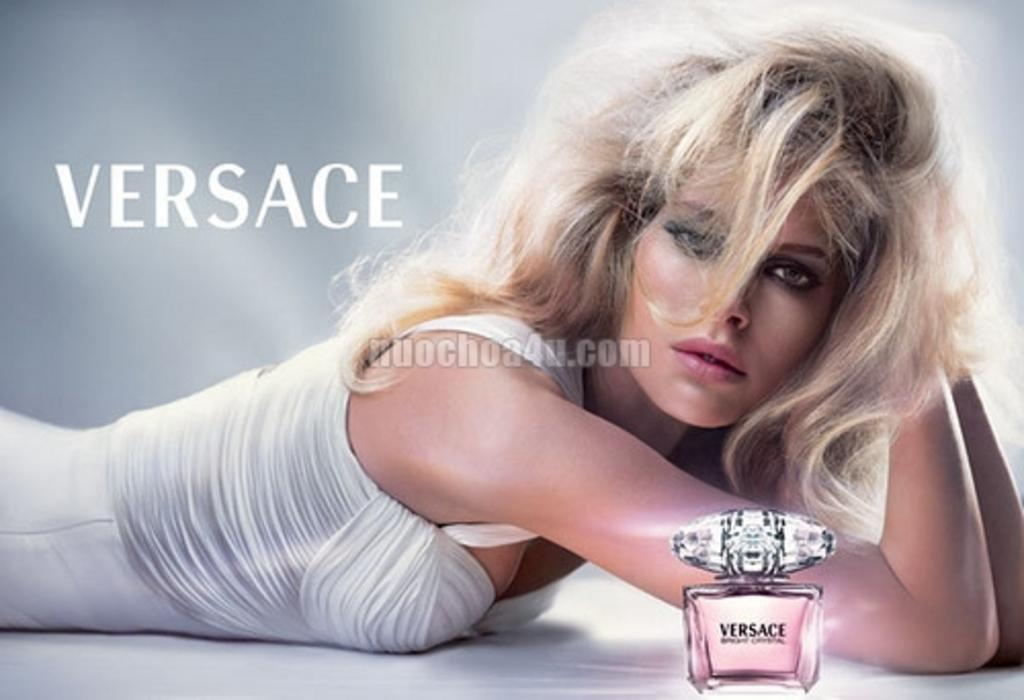<image>
Provide a brief description of the given image. A Versace ad features a sultry blonde model lying on her stomach. 